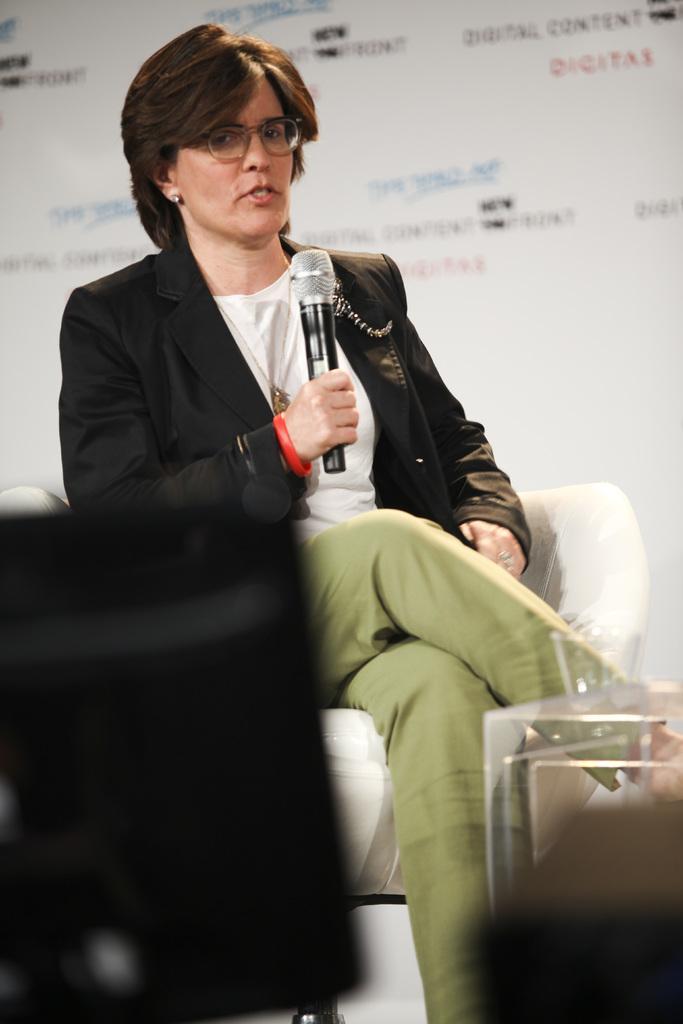How would you summarize this image in a sentence or two? In the image there is a woman in black suit talking on mic, she is sitting on white chair and behind her there is a white banner. 